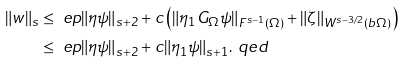<formula> <loc_0><loc_0><loc_500><loc_500>\| w \| _ { s } & \leq \ e p \| \eta \psi \| _ { s + 2 } + c \left ( \| \eta _ { 1 } G _ { \Omega } \psi \| _ { F ^ { s - 1 } ( \Omega ) } + \| \zeta \| _ { W ^ { s - 3 / 2 } ( b \Omega ) } \right ) \\ & \leq \ e p \| \eta \psi \| _ { s + 2 } + c \| \eta _ { 1 } \psi \| _ { s + 1 } . \ q e d</formula> 